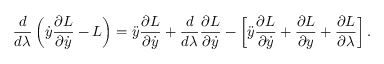<formula> <loc_0><loc_0><loc_500><loc_500>\frac { d } { d \lambda } \left ( \dot { y } \frac { \partial L } { \partial \dot { y } } - L \right ) = \ddot { y } \frac { \partial L } { \partial \dot { y } } + \frac { d } { d \lambda } \frac { \partial L } { \partial \dot { y } } - \left [ \ddot { y } \frac { \partial L } { \partial \dot { y } } + \frac { \partial L } { \partial y } + \frac { \partial L } { \partial \lambda } \right ] .</formula> 